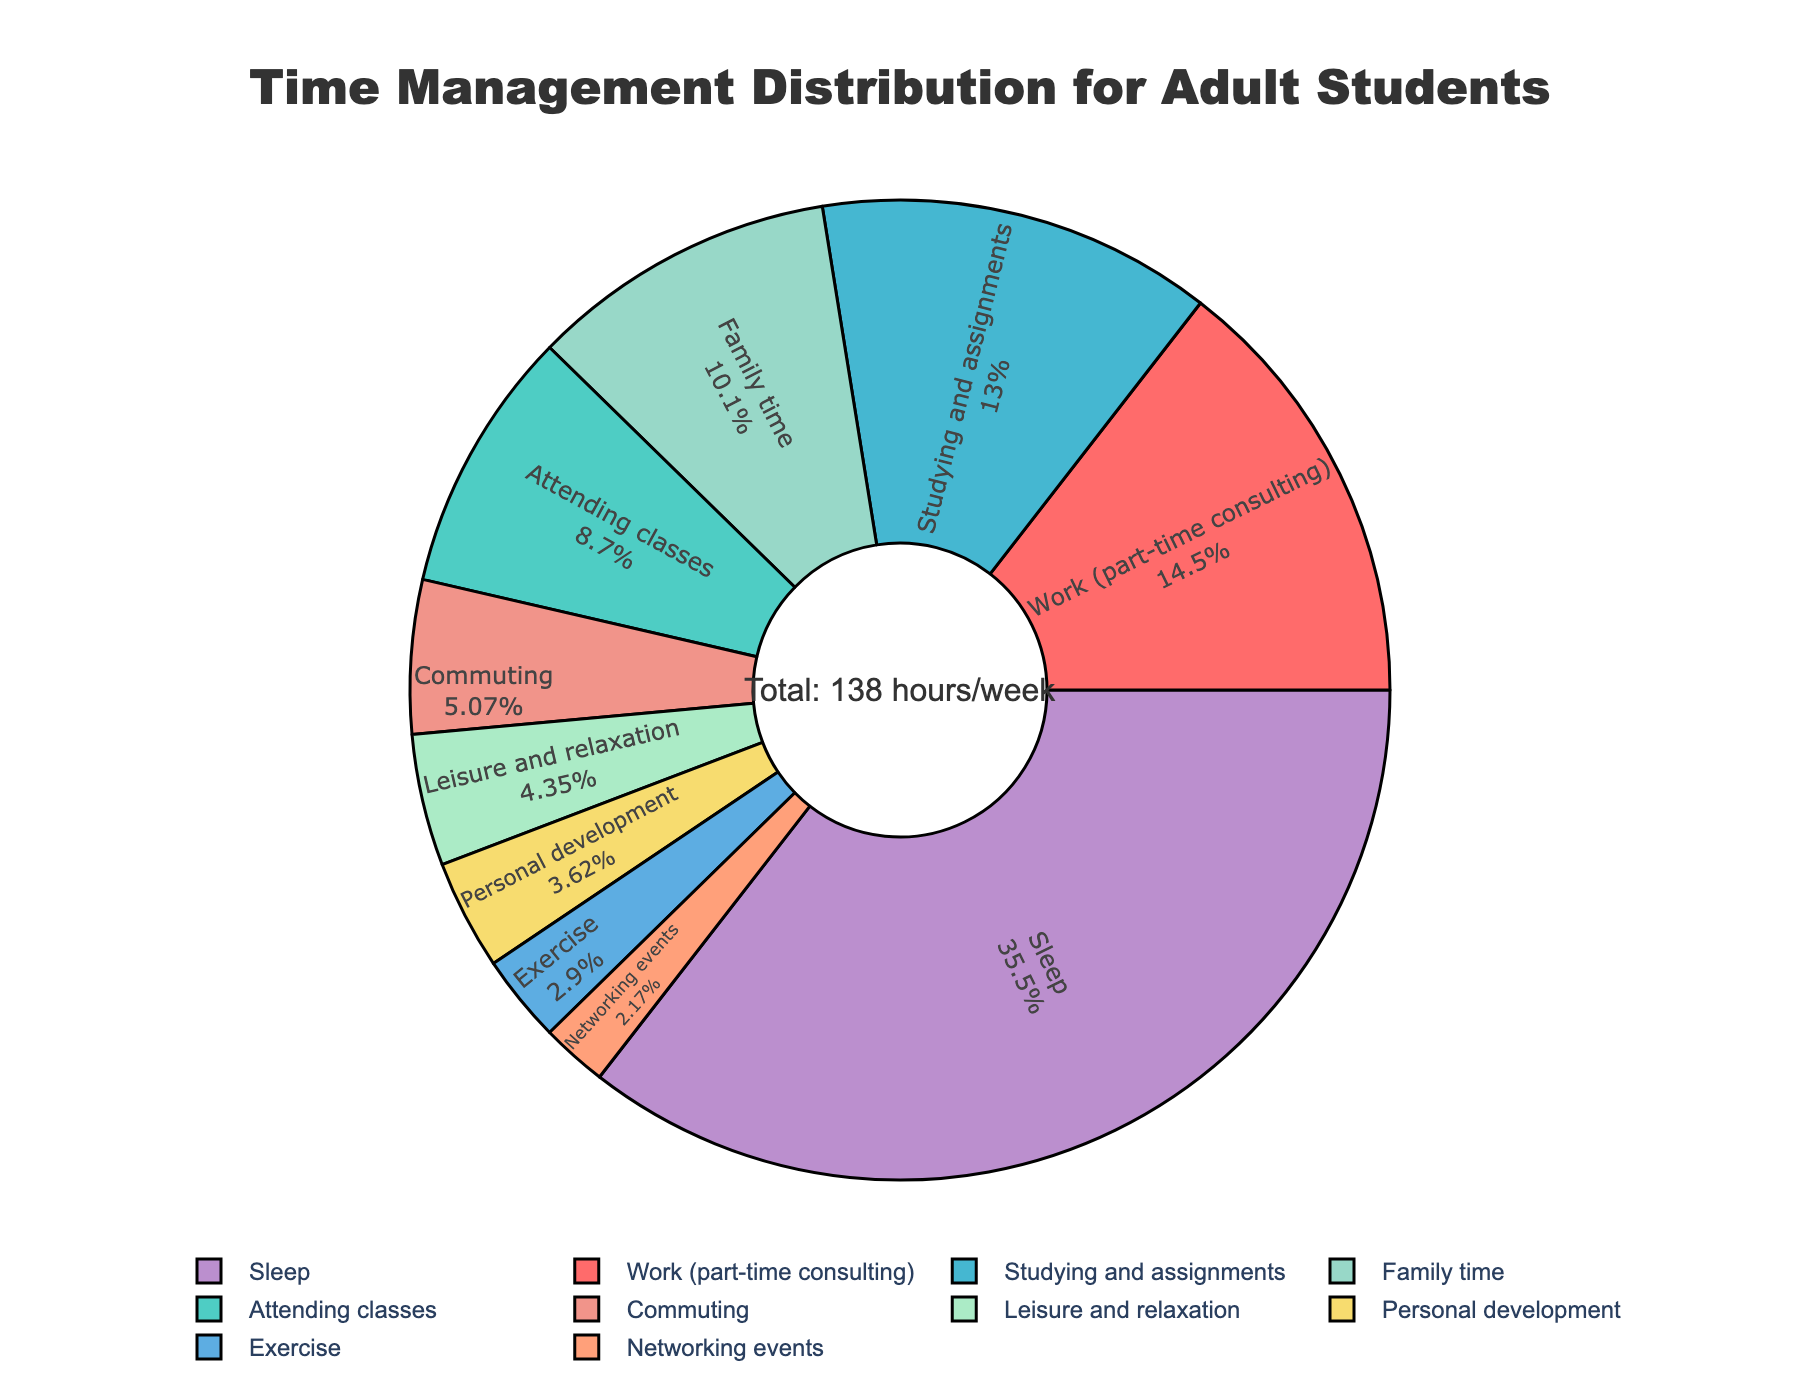What's the total percentage of time spent on work and attending classes? Sum the percentages of work (part-time consulting) and attending classes. Work accounts for approximately 14.49% and attending classes is about 8.70%. Adding them together gives 14.49% + 8.70% = 23.19%.
Answer: 23.19% Which activity takes up more weekly hours, family time or commuting? Family time occupies 14 hours per week, whereas commuting takes 7 hours per week. Therefore, family time takes up more hours.
Answer: Family time What fraction of the week is spent on sleep compared to the total available time? The total available hours in a week is 168. Time spent on sleep is 49 hours. The fraction is 49/168. Simplifying this fraction gives approximately 0.29.
Answer: 0.29 How does the percentage of time spent on studying and assignments compare to personal development? Studying and assignments account for about 13.04% of the time, while personal development is 3.62%. Therefore, studying and assignments take up a larger percentage.
Answer: Greater Which activity has the smallest percentage of time allocation? Network events have 3 hours per week, converting to a percentage of 2.17%, which is the smallest percentage.
Answer: Networking events What's the difference in hours per week spent on sleeping and studying & assignments? Sleep occupies 49 hours per week, whereas studying and assignments take 18 hours per week. The difference is 49 - 18 = 31 hours.
Answer: 31 hours What is the total percentage of time spent on health-related activities (sleep and exercise)? Sleep accounts for approximately 35.51% and exercise is about 2.90%. Adding them together gives 35.51% + 2.90% = 38.41%.
Answer: 38.41% 